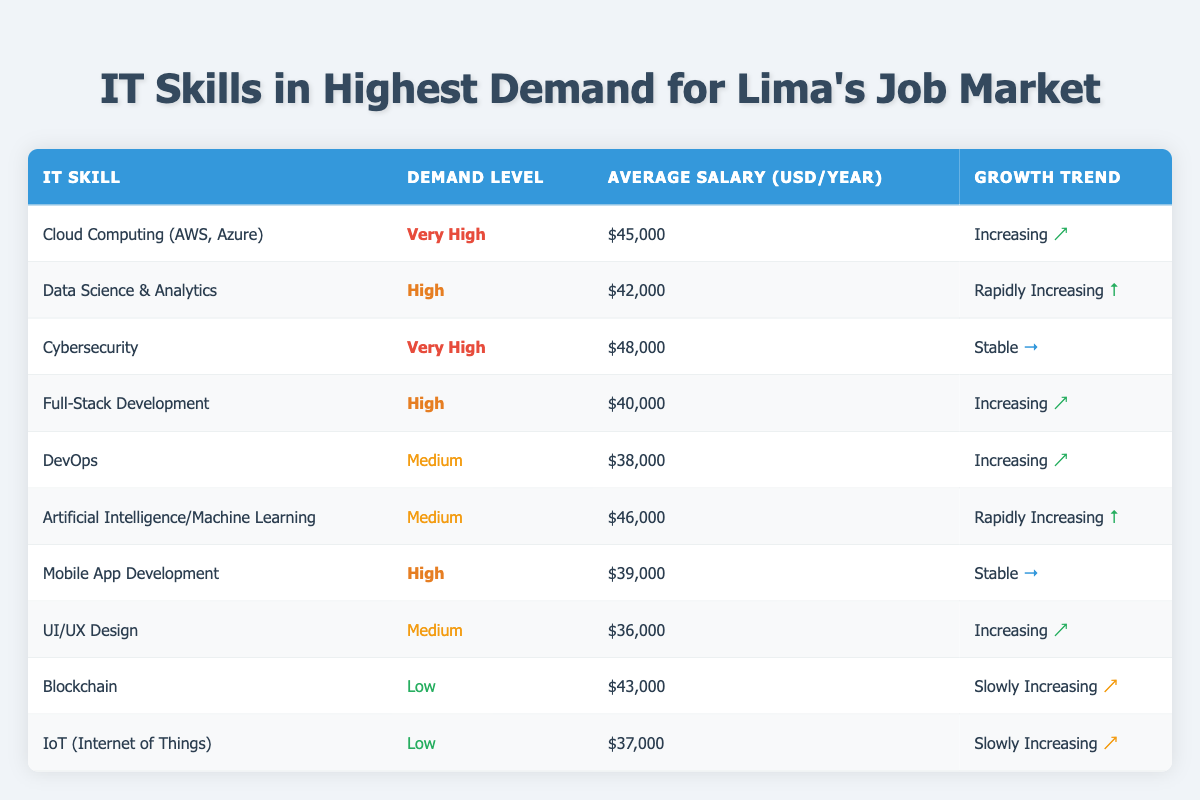What is the average salary for DevOps skills? The average salary for DevOps is listed in the table under "Average Salary (USD/year)", which shows $38,000.
Answer: $38,000 Which IT skill has the highest demand level? The demand levels are ranked in the table, with "Very High" demand listed for Cloud Computing and Cybersecurity.
Answer: Cloud Computing and Cybersecurity Is the average salary for Data Science & Analytics higher than that of Mobile App Development? The average salary for Data Science & Analytics is $42,000, while Mobile App Development is $39,000. Since $42,000 is greater than $39,000, the statement is true.
Answer: Yes What is the difference in average salary between Cybersecurity and UI/UX Design? Cybersecurity has an average salary of $48,000, and UI/UX Design has an average salary of $36,000. The difference is $48,000 - $36,000 = $12,000.
Answer: $12,000 Are there more IT skills with a "Medium" demand level or "High" demand level? There are four skills with a "Medium" demand level (DevOps, Artificial Intelligence/Machine Learning, UI/UX Design, IoT) and three skills with a "High" demand level (Data Science & Analytics, Full-Stack Development, Mobile App Development). Since 4 is greater than 3, there are more medium-demand skills.
Answer: Medium Which skill is experiencing a "Rapidly Increasing" growth trend and what is its average salary? The skills experiencing a "Rapidly Increasing" growth trend are Data Science & Analytics and Artificial Intelligence/Machine Learning, with average salaries of $42,000 and $46,000, respectively.
Answer: Data Science & Analytics ($42,000) and Artificial Intelligence/Machine Learning ($46,000) How many IT skills have a "Low" demand level? The table shows two IT skills with a "Low" demand level: Blockchain and IoT (Internet of Things). Thus, the number of skills is two.
Answer: 2 Is it true that Mobile App Development has a higher average salary compared to Blockchain? The average salary for Mobile App Development is $39,000, and for Blockchain, it is $43,000. Since $39,000 is less than $43,000, the statement is false.
Answer: No What is the average salary for all skills classified as "High" demand? The average salary for high-demand skills can be calculated by adding the salaries of Data Science & Analytics ($42,000), Full-Stack Development ($40,000), and Mobile App Development ($39,000). The total is $42,000 + $40,000 + $39,000 = $121,000. Dividing this by 3 (the number of high-demand skills) gives an average of $121,000 / 3 = $40,333.33.
Answer: $40,333.33 